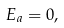<formula> <loc_0><loc_0><loc_500><loc_500>E _ { a } = 0 ,</formula> 